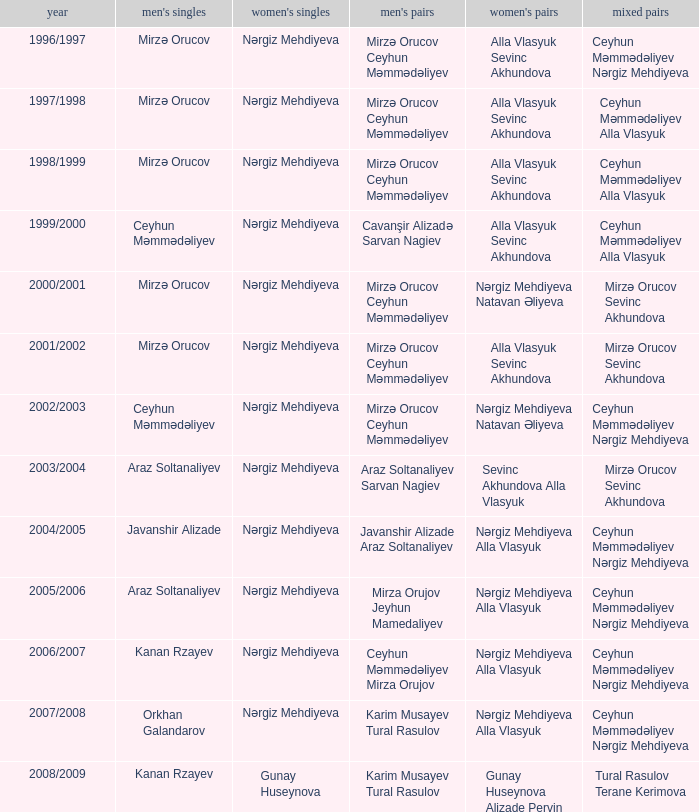What are all values for Womens Doubles in the year 2000/2001? Nərgiz Mehdiyeva Natavan Əliyeva. 